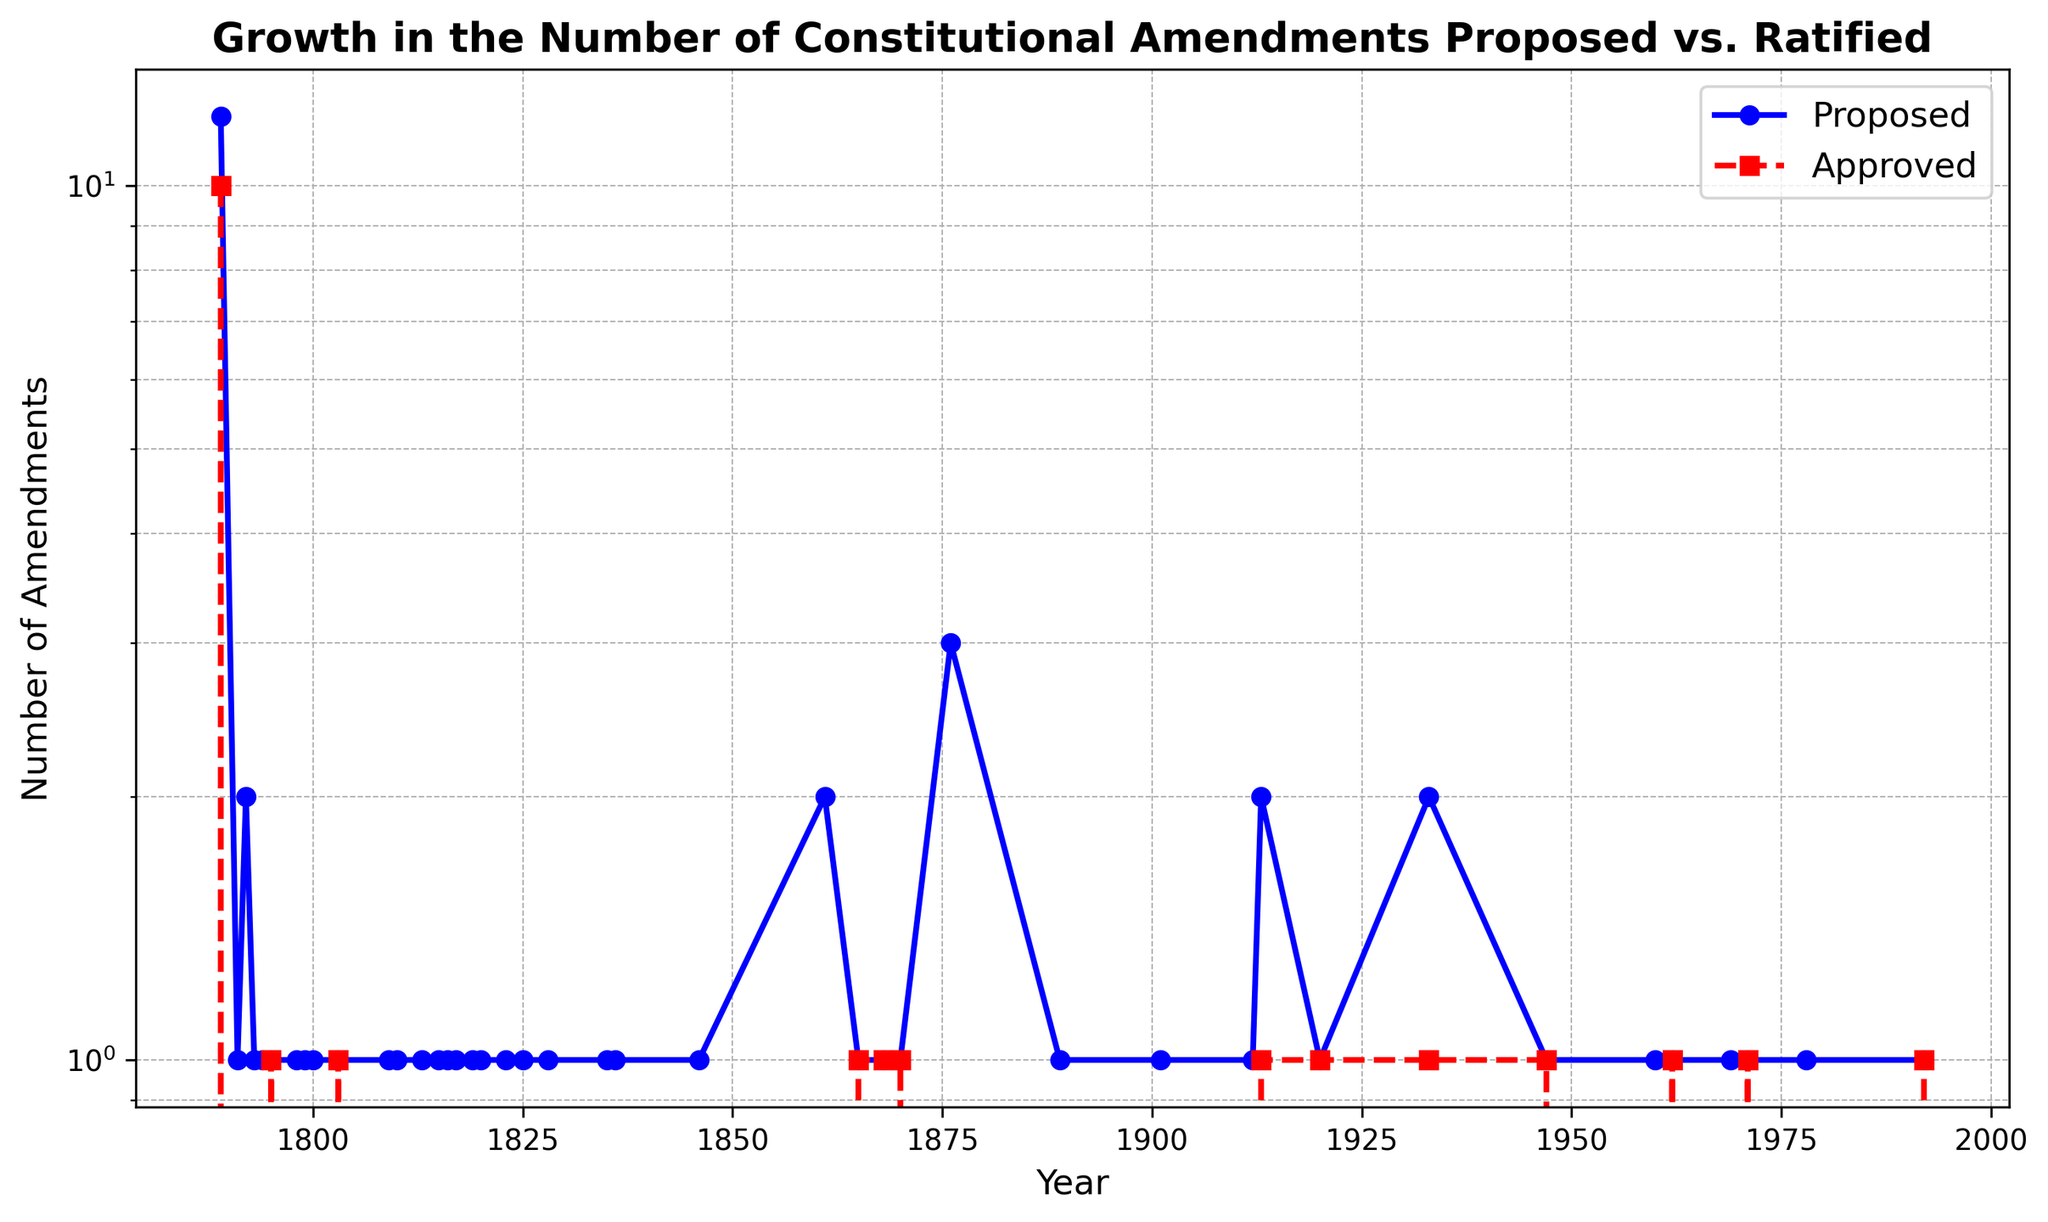What's the overall trend in the number of proposed constitutional amendments over time? By looking at the blue line representing "Proposed", we notice that there is a general increase in the number of proposed amendments from 1789 to 1992. There are, however, several periods of low or zero activities. Overall, the trend is slightly upward.
Answer: Slight increase How many amendments were approved between 1865 and 1870? By looking at the red line and examining the specific years 1865 and 1870, there were approved amendments in 1865, 1868, and 1870. Adding these: 1 (1865) + 1 (1868) + 1 (1870) = 3.
Answer: 3 What is the ratio of proposed to approved amendments in 1933? In 1933, the blue line shows 2 proposed amendments, and the red line shows 1 approved amendment. Therefore, the ratio is 2:1.
Answer: 2:1 Between which consecutive years was the largest increase in the number of proposed amendments? By examining the blue line, you can observe the largest jump between consecutive years from 1870 to 1876, where the proposed amendments increased from 1 to 3.
Answer: 1870-1876 How many times were more amendments proposed than approved across the entire period? By comparing the blue and red lines, we can count the instances where the blue line is above the red line:
- 1789, 1791, 1792, 1793, 1794, 1798, 1799, 1800, 1809, 1810, 1813, 1815, 1816, 1817, 1819, 1820, 1823, 1825, 1828, 1835, 1836, 1846, 1861, 1876, 1889, 1901, 1912, 1960, 1969, 1978. Total = 30 times.
Answer: 30 During which year were the number of proposed and approved amendments equal? By looking for the points where the blue and red lines intersect (years where these values are the same), it occurred in 1795, 1803, 1865, 1868, 1870, 1913, 1920, 1933, 1947, 1962, 1971, 1992.
Answer: 12 years Across which decade was there the highest number of total amendments (proposed + approved)? Adding the number of proposed and approved amendments per decade:
- 1780s: 12+10 = 22
- 1790s: 1+0+2+0+1+0+1+1 = 6
- 1800s: 1+0+1+0+1+0 = 3
- 1860s: 2+0 = 2
- 1870s: 5+3 = 8
- 1880s: 1+0 = 1
- 1960s: 2+1 = 3
- 1970s: 1+1 = 2
- 1990s: 1+1 = 2
Thus, the 1780s had the highest total of 22 amendments.
Answer: 1780s How many amendments were proposed but not approved during the 20th century (1901-1992)? By summing the proposed but not approved amendments:
- 1901: 1+0
- 1912: 1+0
- 1913: 2-1 = 1
- 1920: 1-1 = 0
- 1933: 2-1 = 1
- 1947: 1-1 = 0
- 1960: 1
- 1962: 1-1 = 0
- 1969: 1
- 1971: 1-1
- 1978: 1
- 1992: 1-1 = 0
Thus, (1+1+0+1 = 3, 1+0+1+1) = 7
Answer: 7 